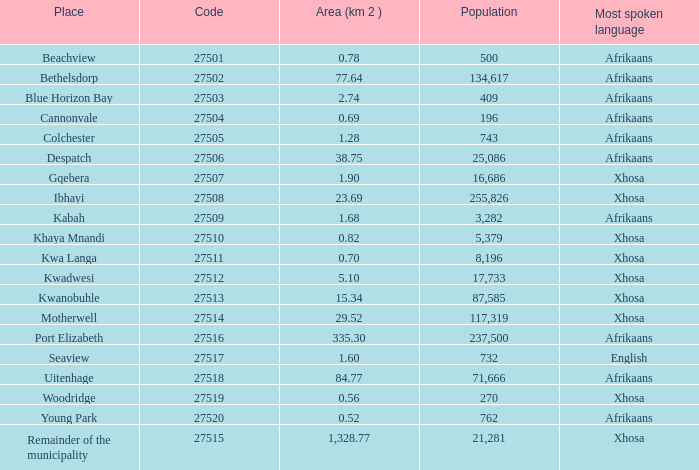What is the total number of area listed for cannonvale with a population less than 409? 1.0. 